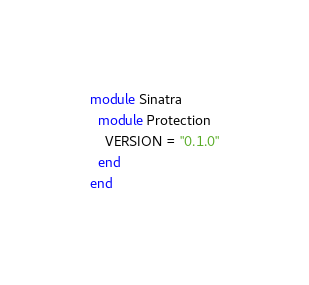<code> <loc_0><loc_0><loc_500><loc_500><_Ruby_>module Sinatra
  module Protection
    VERSION = "0.1.0"
  end
end
</code> 